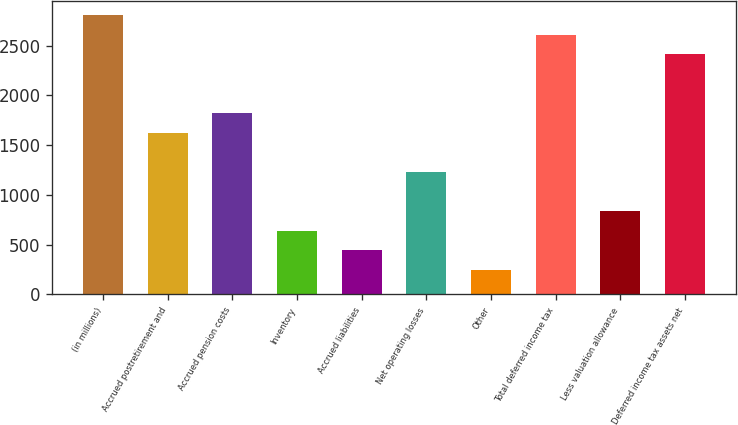Convert chart to OTSL. <chart><loc_0><loc_0><loc_500><loc_500><bar_chart><fcel>(in millions)<fcel>Accrued postretirement and<fcel>Accrued pension costs<fcel>Inventory<fcel>Accrued liabilities<fcel>Net operating losses<fcel>Other<fcel>Total deferred income tax<fcel>Less valuation allowance<fcel>Deferred income tax assets net<nl><fcel>2804.2<fcel>1623.4<fcel>1820.2<fcel>639.4<fcel>442.6<fcel>1229.8<fcel>245.8<fcel>2607.4<fcel>836.2<fcel>2410.6<nl></chart> 